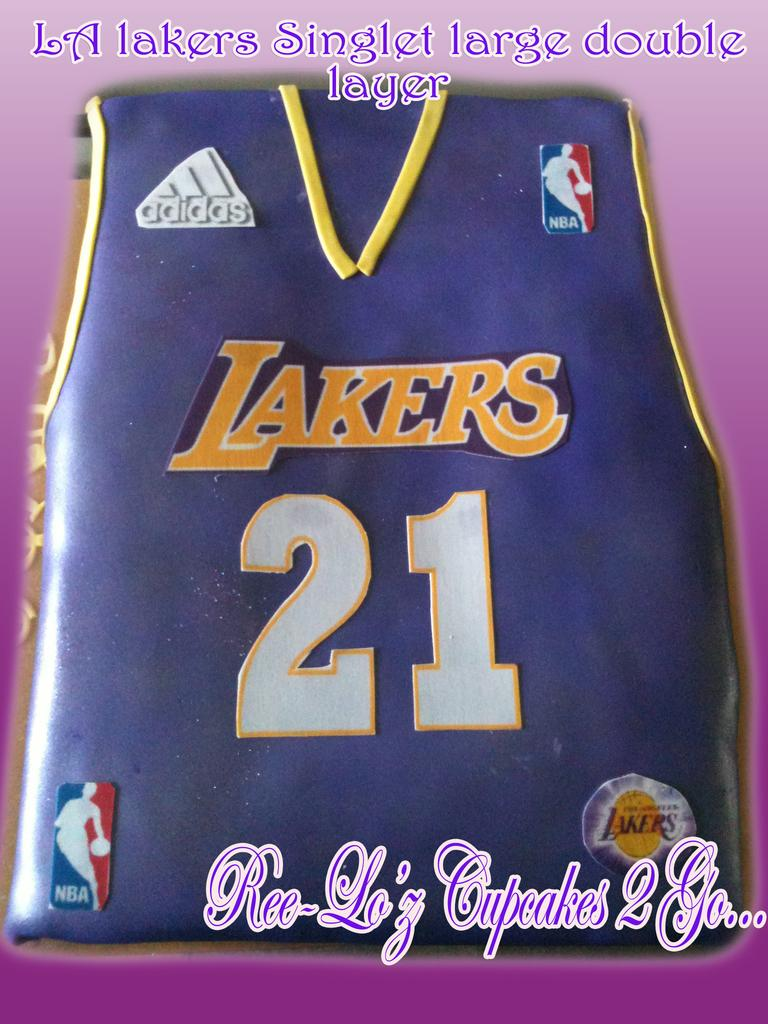<image>
Give a short and clear explanation of the subsequent image. A cake from Ree Lo'z cupcakes 2 go is designed to look like the shirt of an LA Lakers player. 